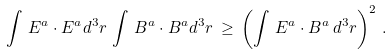Convert formula to latex. <formula><loc_0><loc_0><loc_500><loc_500>\int \, E ^ { a } \cdot E ^ { a } d ^ { 3 } r \, \int \, B ^ { a } \cdot B ^ { a } d ^ { 3 } r \, \geq \, \left ( \int \, E ^ { a } \cdot B ^ { a } \, d ^ { 3 } r \right ) ^ { 2 } \, .</formula> 